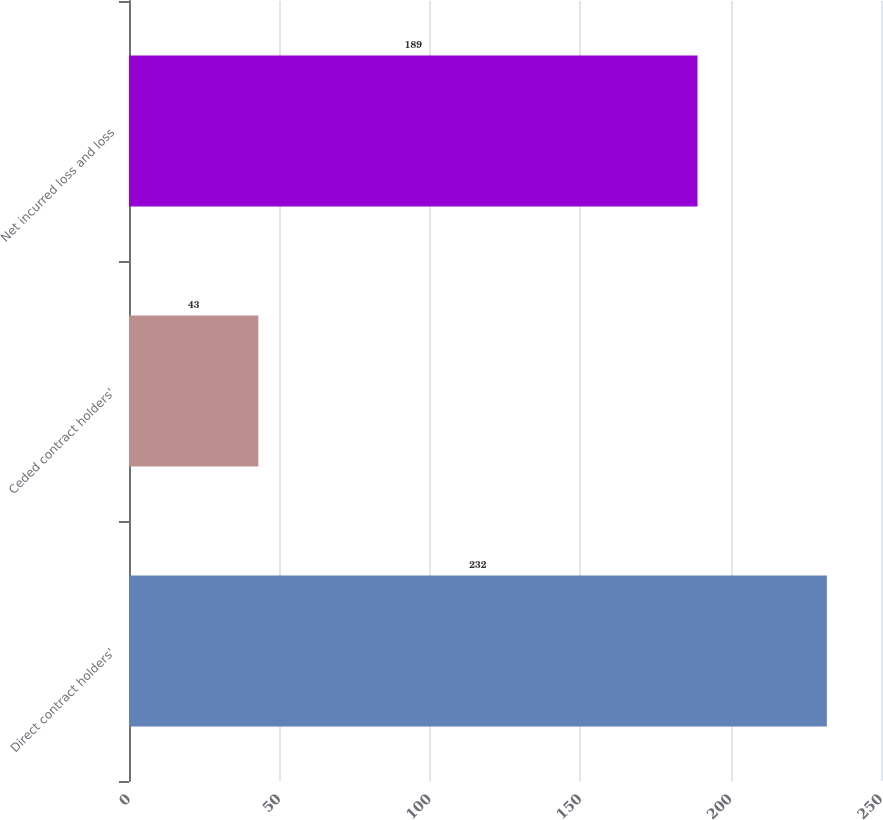<chart> <loc_0><loc_0><loc_500><loc_500><bar_chart><fcel>Direct contract holders'<fcel>Ceded contract holders'<fcel>Net incurred loss and loss<nl><fcel>232<fcel>43<fcel>189<nl></chart> 